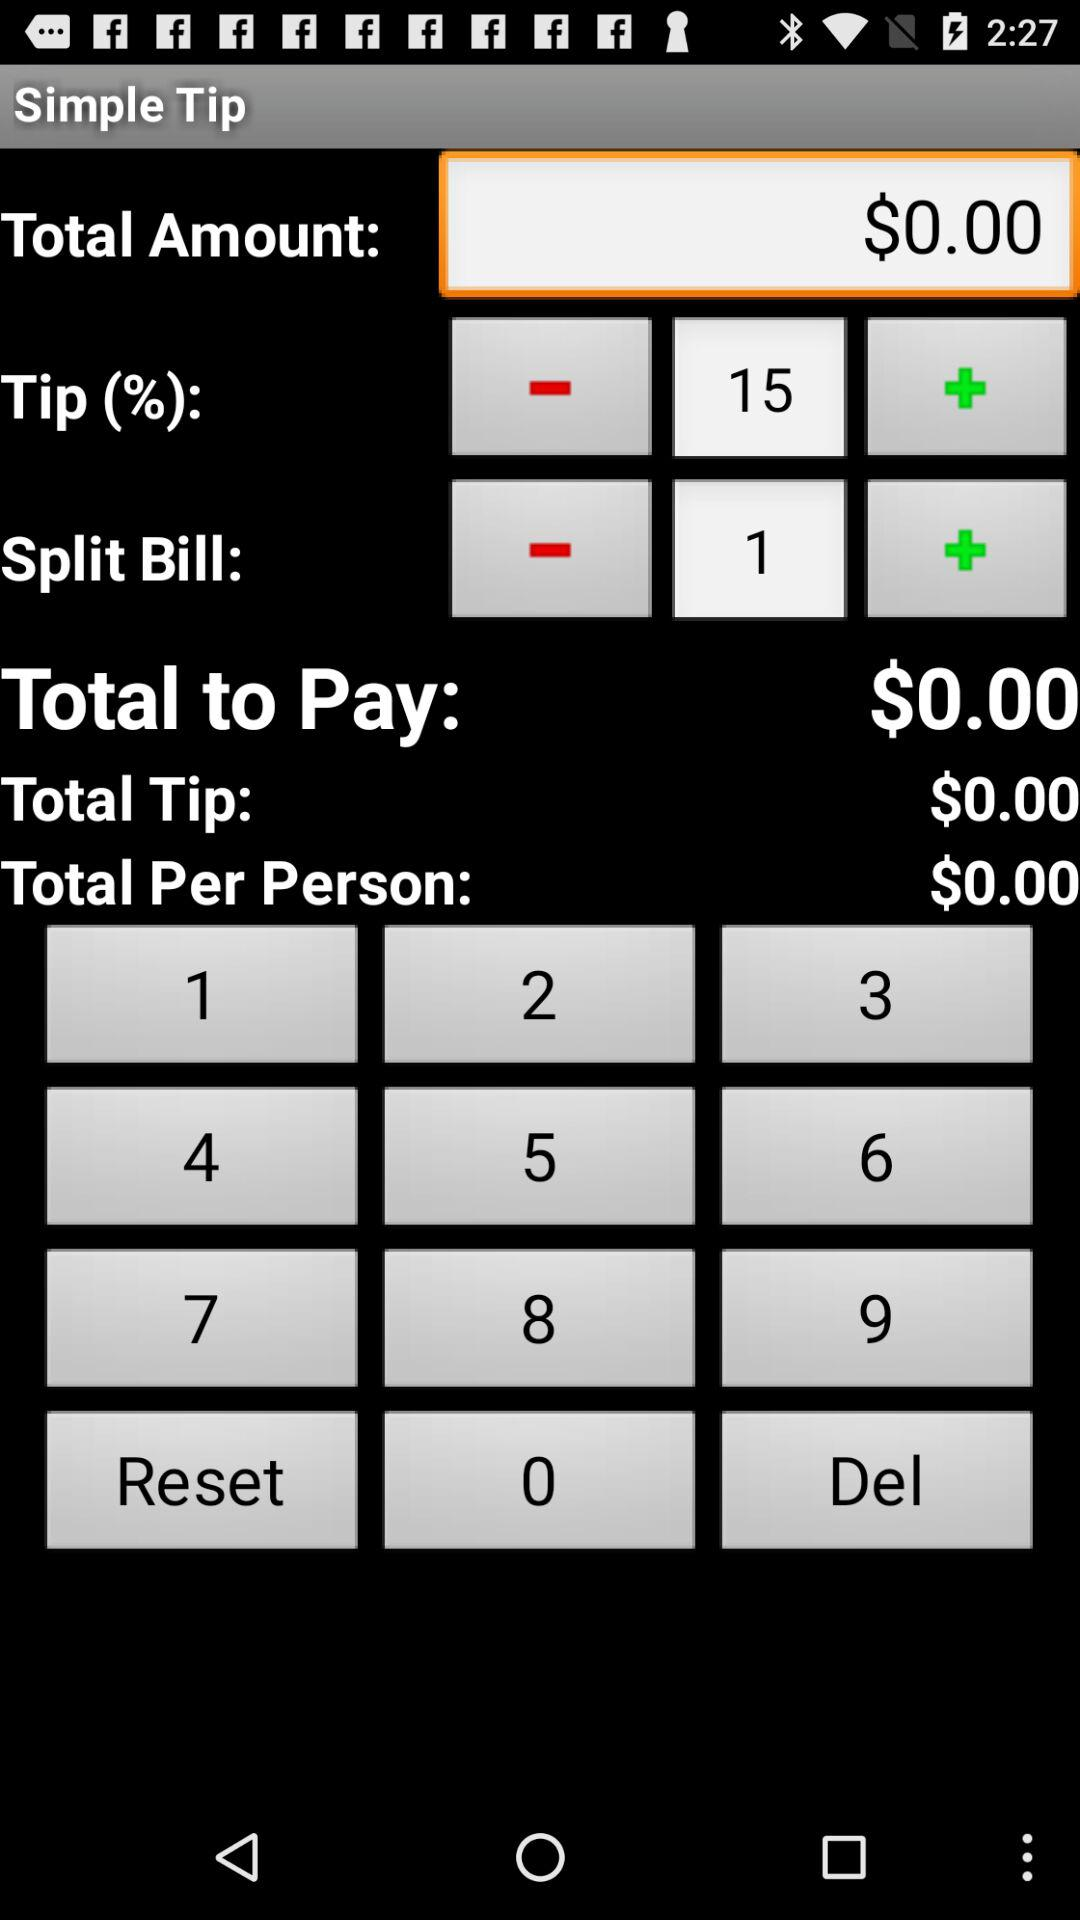How much is the total amount to pay? The total amount to pay is $0.00. 